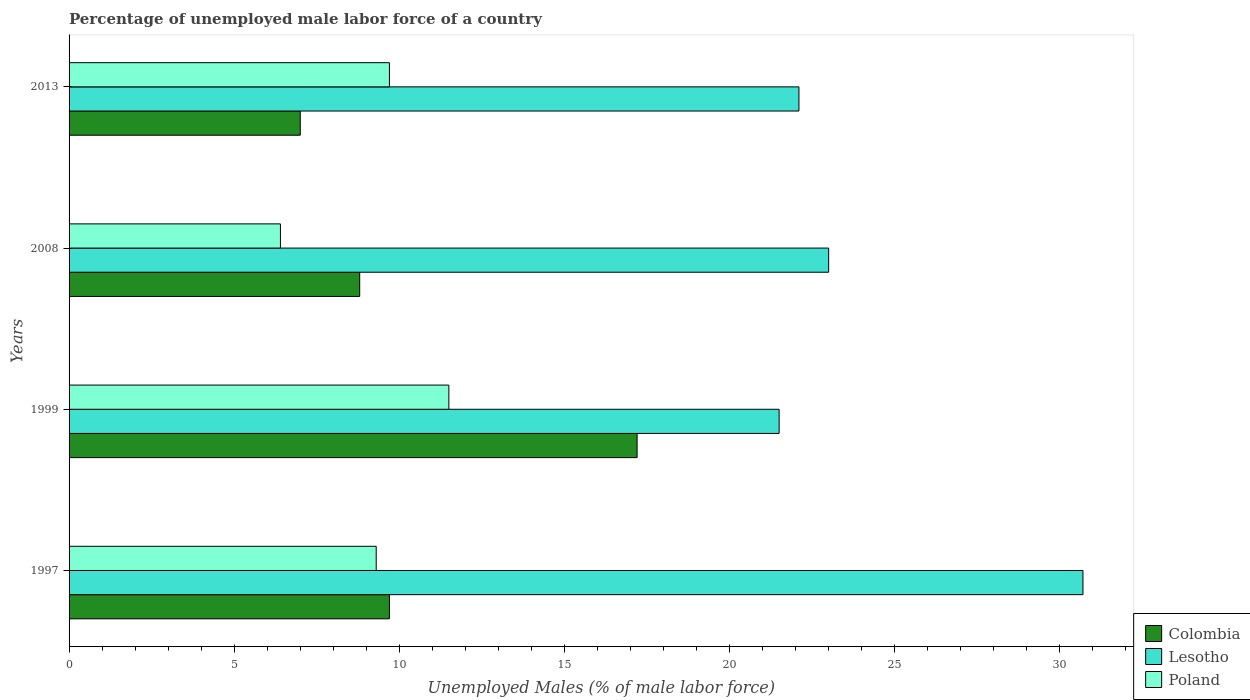How many groups of bars are there?
Ensure brevity in your answer.  4. Are the number of bars on each tick of the Y-axis equal?
Keep it short and to the point. Yes. How many bars are there on the 2nd tick from the top?
Provide a succinct answer. 3. Across all years, what is the maximum percentage of unemployed male labor force in Poland?
Provide a succinct answer. 11.5. In which year was the percentage of unemployed male labor force in Colombia maximum?
Give a very brief answer. 1999. In which year was the percentage of unemployed male labor force in Colombia minimum?
Keep it short and to the point. 2013. What is the total percentage of unemployed male labor force in Poland in the graph?
Provide a short and direct response. 36.9. What is the difference between the percentage of unemployed male labor force in Colombia in 1999 and that in 2013?
Your response must be concise. 10.2. What is the difference between the percentage of unemployed male labor force in Lesotho in 2008 and the percentage of unemployed male labor force in Poland in 1999?
Your answer should be very brief. 11.5. What is the average percentage of unemployed male labor force in Lesotho per year?
Ensure brevity in your answer.  24.33. In the year 1999, what is the difference between the percentage of unemployed male labor force in Lesotho and percentage of unemployed male labor force in Colombia?
Provide a succinct answer. 4.3. In how many years, is the percentage of unemployed male labor force in Poland greater than 12 %?
Your answer should be compact. 0. What is the ratio of the percentage of unemployed male labor force in Colombia in 1999 to that in 2013?
Give a very brief answer. 2.46. What is the difference between the highest and the second highest percentage of unemployed male labor force in Lesotho?
Offer a terse response. 7.7. What is the difference between the highest and the lowest percentage of unemployed male labor force in Colombia?
Make the answer very short. 10.2. In how many years, is the percentage of unemployed male labor force in Lesotho greater than the average percentage of unemployed male labor force in Lesotho taken over all years?
Your response must be concise. 1. What does the 2nd bar from the top in 1997 represents?
Provide a short and direct response. Lesotho. Is it the case that in every year, the sum of the percentage of unemployed male labor force in Colombia and percentage of unemployed male labor force in Poland is greater than the percentage of unemployed male labor force in Lesotho?
Ensure brevity in your answer.  No. How many bars are there?
Your response must be concise. 12. What is the difference between two consecutive major ticks on the X-axis?
Your response must be concise. 5. Are the values on the major ticks of X-axis written in scientific E-notation?
Offer a very short reply. No. Does the graph contain grids?
Offer a terse response. No. Where does the legend appear in the graph?
Your answer should be very brief. Bottom right. How many legend labels are there?
Make the answer very short. 3. What is the title of the graph?
Your answer should be very brief. Percentage of unemployed male labor force of a country. Does "Germany" appear as one of the legend labels in the graph?
Keep it short and to the point. No. What is the label or title of the X-axis?
Keep it short and to the point. Unemployed Males (% of male labor force). What is the label or title of the Y-axis?
Your answer should be compact. Years. What is the Unemployed Males (% of male labor force) of Colombia in 1997?
Provide a succinct answer. 9.7. What is the Unemployed Males (% of male labor force) in Lesotho in 1997?
Your answer should be very brief. 30.7. What is the Unemployed Males (% of male labor force) of Poland in 1997?
Provide a short and direct response. 9.3. What is the Unemployed Males (% of male labor force) in Colombia in 1999?
Offer a very short reply. 17.2. What is the Unemployed Males (% of male labor force) of Colombia in 2008?
Your answer should be very brief. 8.8. What is the Unemployed Males (% of male labor force) in Poland in 2008?
Make the answer very short. 6.4. What is the Unemployed Males (% of male labor force) in Colombia in 2013?
Provide a short and direct response. 7. What is the Unemployed Males (% of male labor force) of Lesotho in 2013?
Provide a short and direct response. 22.1. What is the Unemployed Males (% of male labor force) in Poland in 2013?
Your response must be concise. 9.7. Across all years, what is the maximum Unemployed Males (% of male labor force) of Colombia?
Make the answer very short. 17.2. Across all years, what is the maximum Unemployed Males (% of male labor force) of Lesotho?
Your answer should be very brief. 30.7. Across all years, what is the minimum Unemployed Males (% of male labor force) in Colombia?
Provide a succinct answer. 7. Across all years, what is the minimum Unemployed Males (% of male labor force) of Poland?
Ensure brevity in your answer.  6.4. What is the total Unemployed Males (% of male labor force) of Colombia in the graph?
Provide a succinct answer. 42.7. What is the total Unemployed Males (% of male labor force) in Lesotho in the graph?
Offer a very short reply. 97.3. What is the total Unemployed Males (% of male labor force) in Poland in the graph?
Give a very brief answer. 36.9. What is the difference between the Unemployed Males (% of male labor force) in Poland in 1997 and that in 1999?
Offer a very short reply. -2.2. What is the difference between the Unemployed Males (% of male labor force) in Colombia in 1997 and that in 2013?
Offer a very short reply. 2.7. What is the difference between the Unemployed Males (% of male labor force) in Lesotho in 1997 and that in 2013?
Keep it short and to the point. 8.6. What is the difference between the Unemployed Males (% of male labor force) in Poland in 1997 and that in 2013?
Provide a short and direct response. -0.4. What is the difference between the Unemployed Males (% of male labor force) in Colombia in 1999 and that in 2008?
Provide a succinct answer. 8.4. What is the difference between the Unemployed Males (% of male labor force) in Poland in 1999 and that in 2008?
Offer a very short reply. 5.1. What is the difference between the Unemployed Males (% of male labor force) in Lesotho in 1999 and that in 2013?
Ensure brevity in your answer.  -0.6. What is the difference between the Unemployed Males (% of male labor force) in Poland in 1999 and that in 2013?
Your answer should be very brief. 1.8. What is the difference between the Unemployed Males (% of male labor force) of Lesotho in 2008 and that in 2013?
Your answer should be very brief. 0.9. What is the difference between the Unemployed Males (% of male labor force) in Poland in 2008 and that in 2013?
Provide a succinct answer. -3.3. What is the difference between the Unemployed Males (% of male labor force) in Colombia in 1997 and the Unemployed Males (% of male labor force) in Lesotho in 1999?
Your answer should be very brief. -11.8. What is the difference between the Unemployed Males (% of male labor force) in Colombia in 1997 and the Unemployed Males (% of male labor force) in Poland in 1999?
Offer a terse response. -1.8. What is the difference between the Unemployed Males (% of male labor force) of Colombia in 1997 and the Unemployed Males (% of male labor force) of Poland in 2008?
Offer a terse response. 3.3. What is the difference between the Unemployed Males (% of male labor force) of Lesotho in 1997 and the Unemployed Males (% of male labor force) of Poland in 2008?
Provide a succinct answer. 24.3. What is the difference between the Unemployed Males (% of male labor force) of Colombia in 1997 and the Unemployed Males (% of male labor force) of Lesotho in 2013?
Your answer should be compact. -12.4. What is the difference between the Unemployed Males (% of male labor force) of Colombia in 1999 and the Unemployed Males (% of male labor force) of Lesotho in 2008?
Provide a short and direct response. -5.8. What is the difference between the Unemployed Males (% of male labor force) of Colombia in 1999 and the Unemployed Males (% of male labor force) of Poland in 2008?
Give a very brief answer. 10.8. What is the difference between the Unemployed Males (% of male labor force) of Lesotho in 1999 and the Unemployed Males (% of male labor force) of Poland in 2008?
Provide a succinct answer. 15.1. What is the difference between the Unemployed Males (% of male labor force) of Colombia in 1999 and the Unemployed Males (% of male labor force) of Lesotho in 2013?
Ensure brevity in your answer.  -4.9. What is the difference between the Unemployed Males (% of male labor force) in Lesotho in 1999 and the Unemployed Males (% of male labor force) in Poland in 2013?
Keep it short and to the point. 11.8. What is the difference between the Unemployed Males (% of male labor force) in Colombia in 2008 and the Unemployed Males (% of male labor force) in Lesotho in 2013?
Give a very brief answer. -13.3. What is the difference between the Unemployed Males (% of male labor force) of Colombia in 2008 and the Unemployed Males (% of male labor force) of Poland in 2013?
Your response must be concise. -0.9. What is the average Unemployed Males (% of male labor force) of Colombia per year?
Provide a succinct answer. 10.68. What is the average Unemployed Males (% of male labor force) in Lesotho per year?
Keep it short and to the point. 24.32. What is the average Unemployed Males (% of male labor force) in Poland per year?
Offer a very short reply. 9.22. In the year 1997, what is the difference between the Unemployed Males (% of male labor force) in Lesotho and Unemployed Males (% of male labor force) in Poland?
Offer a terse response. 21.4. In the year 1999, what is the difference between the Unemployed Males (% of male labor force) in Colombia and Unemployed Males (% of male labor force) in Lesotho?
Provide a succinct answer. -4.3. In the year 1999, what is the difference between the Unemployed Males (% of male labor force) in Lesotho and Unemployed Males (% of male labor force) in Poland?
Your answer should be compact. 10. In the year 2008, what is the difference between the Unemployed Males (% of male labor force) in Colombia and Unemployed Males (% of male labor force) in Lesotho?
Keep it short and to the point. -14.2. In the year 2008, what is the difference between the Unemployed Males (% of male labor force) in Lesotho and Unemployed Males (% of male labor force) in Poland?
Your response must be concise. 16.6. In the year 2013, what is the difference between the Unemployed Males (% of male labor force) in Colombia and Unemployed Males (% of male labor force) in Lesotho?
Provide a short and direct response. -15.1. In the year 2013, what is the difference between the Unemployed Males (% of male labor force) of Lesotho and Unemployed Males (% of male labor force) of Poland?
Offer a very short reply. 12.4. What is the ratio of the Unemployed Males (% of male labor force) of Colombia in 1997 to that in 1999?
Make the answer very short. 0.56. What is the ratio of the Unemployed Males (% of male labor force) of Lesotho in 1997 to that in 1999?
Provide a short and direct response. 1.43. What is the ratio of the Unemployed Males (% of male labor force) in Poland in 1997 to that in 1999?
Make the answer very short. 0.81. What is the ratio of the Unemployed Males (% of male labor force) in Colombia in 1997 to that in 2008?
Make the answer very short. 1.1. What is the ratio of the Unemployed Males (% of male labor force) of Lesotho in 1997 to that in 2008?
Provide a short and direct response. 1.33. What is the ratio of the Unemployed Males (% of male labor force) in Poland in 1997 to that in 2008?
Ensure brevity in your answer.  1.45. What is the ratio of the Unemployed Males (% of male labor force) in Colombia in 1997 to that in 2013?
Ensure brevity in your answer.  1.39. What is the ratio of the Unemployed Males (% of male labor force) in Lesotho in 1997 to that in 2013?
Your answer should be compact. 1.39. What is the ratio of the Unemployed Males (% of male labor force) of Poland in 1997 to that in 2013?
Provide a succinct answer. 0.96. What is the ratio of the Unemployed Males (% of male labor force) in Colombia in 1999 to that in 2008?
Ensure brevity in your answer.  1.95. What is the ratio of the Unemployed Males (% of male labor force) of Lesotho in 1999 to that in 2008?
Give a very brief answer. 0.93. What is the ratio of the Unemployed Males (% of male labor force) of Poland in 1999 to that in 2008?
Your answer should be compact. 1.8. What is the ratio of the Unemployed Males (% of male labor force) in Colombia in 1999 to that in 2013?
Provide a succinct answer. 2.46. What is the ratio of the Unemployed Males (% of male labor force) in Lesotho in 1999 to that in 2013?
Keep it short and to the point. 0.97. What is the ratio of the Unemployed Males (% of male labor force) in Poland in 1999 to that in 2013?
Offer a terse response. 1.19. What is the ratio of the Unemployed Males (% of male labor force) in Colombia in 2008 to that in 2013?
Offer a terse response. 1.26. What is the ratio of the Unemployed Males (% of male labor force) of Lesotho in 2008 to that in 2013?
Offer a very short reply. 1.04. What is the ratio of the Unemployed Males (% of male labor force) in Poland in 2008 to that in 2013?
Ensure brevity in your answer.  0.66. What is the difference between the highest and the second highest Unemployed Males (% of male labor force) of Colombia?
Your answer should be compact. 7.5. What is the difference between the highest and the second highest Unemployed Males (% of male labor force) in Lesotho?
Your answer should be very brief. 7.7. What is the difference between the highest and the lowest Unemployed Males (% of male labor force) in Colombia?
Your answer should be compact. 10.2. 